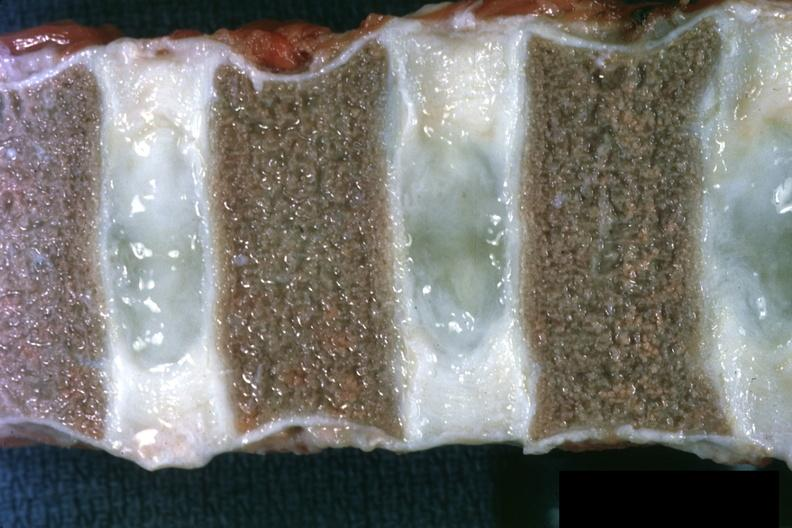re not too spectacular discs well shown?
Answer the question using a single word or phrase. Yes 